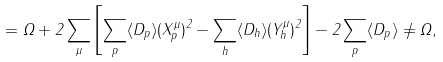<formula> <loc_0><loc_0><loc_500><loc_500>= \Omega + 2 \sum _ { \mu } \left [ \sum _ { p } \langle D _ { p } \rangle ( X _ { p } ^ { \mu } ) ^ { 2 } - \sum _ { h } \langle D _ { h } \rangle ( Y _ { h } ^ { \mu } ) ^ { 2 } \right ] - 2 \sum _ { p } \langle D _ { p } \rangle \neq \Omega ,</formula> 